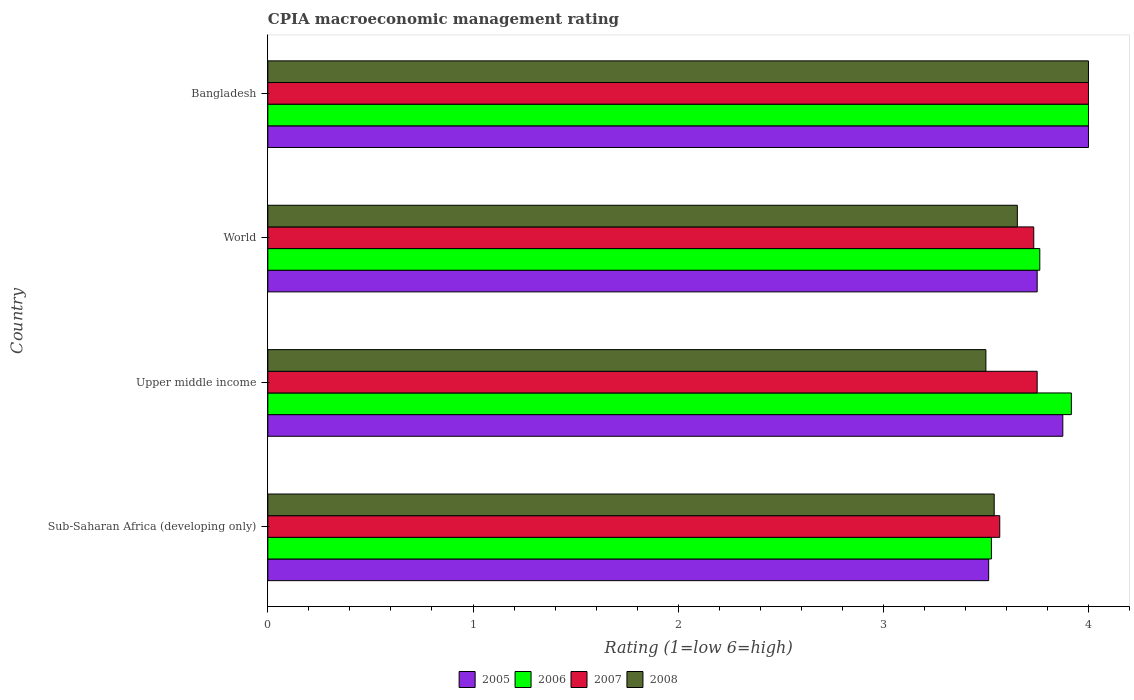Are the number of bars per tick equal to the number of legend labels?
Give a very brief answer. Yes. How many bars are there on the 4th tick from the top?
Give a very brief answer. 4. How many bars are there on the 2nd tick from the bottom?
Your answer should be very brief. 4. What is the label of the 4th group of bars from the top?
Provide a short and direct response. Sub-Saharan Africa (developing only). In how many cases, is the number of bars for a given country not equal to the number of legend labels?
Keep it short and to the point. 0. What is the CPIA rating in 2008 in Bangladesh?
Give a very brief answer. 4. Across all countries, what is the minimum CPIA rating in 2007?
Ensure brevity in your answer.  3.57. In which country was the CPIA rating in 2007 minimum?
Your answer should be compact. Sub-Saharan Africa (developing only). What is the total CPIA rating in 2008 in the graph?
Your answer should be very brief. 14.69. What is the difference between the CPIA rating in 2007 in Bangladesh and the CPIA rating in 2008 in Upper middle income?
Offer a terse response. 0.5. What is the average CPIA rating in 2007 per country?
Provide a short and direct response. 3.76. What is the difference between the CPIA rating in 2005 and CPIA rating in 2008 in Bangladesh?
Offer a very short reply. 0. In how many countries, is the CPIA rating in 2007 greater than 3 ?
Provide a short and direct response. 4. What is the ratio of the CPIA rating in 2008 in Sub-Saharan Africa (developing only) to that in Upper middle income?
Make the answer very short. 1.01. Is the CPIA rating in 2008 in Bangladesh less than that in World?
Offer a terse response. No. What is the difference between the highest and the second highest CPIA rating in 2007?
Ensure brevity in your answer.  0.25. What is the difference between the highest and the lowest CPIA rating in 2007?
Make the answer very short. 0.43. In how many countries, is the CPIA rating in 2005 greater than the average CPIA rating in 2005 taken over all countries?
Offer a terse response. 2. Is the sum of the CPIA rating in 2008 in Bangladesh and Upper middle income greater than the maximum CPIA rating in 2005 across all countries?
Your response must be concise. Yes. What does the 1st bar from the top in Upper middle income represents?
Your answer should be very brief. 2008. What does the 1st bar from the bottom in World represents?
Offer a terse response. 2005. Are all the bars in the graph horizontal?
Provide a short and direct response. Yes. How many countries are there in the graph?
Your answer should be very brief. 4. Does the graph contain any zero values?
Provide a succinct answer. No. How are the legend labels stacked?
Your answer should be compact. Horizontal. What is the title of the graph?
Your answer should be very brief. CPIA macroeconomic management rating. Does "1969" appear as one of the legend labels in the graph?
Offer a terse response. No. What is the label or title of the X-axis?
Make the answer very short. Rating (1=low 6=high). What is the label or title of the Y-axis?
Ensure brevity in your answer.  Country. What is the Rating (1=low 6=high) of 2005 in Sub-Saharan Africa (developing only)?
Your response must be concise. 3.51. What is the Rating (1=low 6=high) of 2006 in Sub-Saharan Africa (developing only)?
Provide a succinct answer. 3.53. What is the Rating (1=low 6=high) in 2007 in Sub-Saharan Africa (developing only)?
Keep it short and to the point. 3.57. What is the Rating (1=low 6=high) in 2008 in Sub-Saharan Africa (developing only)?
Your response must be concise. 3.54. What is the Rating (1=low 6=high) of 2005 in Upper middle income?
Give a very brief answer. 3.88. What is the Rating (1=low 6=high) of 2006 in Upper middle income?
Provide a succinct answer. 3.92. What is the Rating (1=low 6=high) in 2007 in Upper middle income?
Ensure brevity in your answer.  3.75. What is the Rating (1=low 6=high) of 2008 in Upper middle income?
Your response must be concise. 3.5. What is the Rating (1=low 6=high) of 2005 in World?
Give a very brief answer. 3.75. What is the Rating (1=low 6=high) in 2006 in World?
Provide a succinct answer. 3.76. What is the Rating (1=low 6=high) of 2007 in World?
Offer a terse response. 3.73. What is the Rating (1=low 6=high) of 2008 in World?
Your answer should be very brief. 3.65. What is the Rating (1=low 6=high) of 2006 in Bangladesh?
Offer a terse response. 4. What is the Rating (1=low 6=high) of 2007 in Bangladesh?
Your answer should be very brief. 4. Across all countries, what is the maximum Rating (1=low 6=high) of 2006?
Your answer should be compact. 4. Across all countries, what is the maximum Rating (1=low 6=high) in 2007?
Offer a very short reply. 4. Across all countries, what is the minimum Rating (1=low 6=high) in 2005?
Ensure brevity in your answer.  3.51. Across all countries, what is the minimum Rating (1=low 6=high) of 2006?
Provide a succinct answer. 3.53. Across all countries, what is the minimum Rating (1=low 6=high) of 2007?
Offer a terse response. 3.57. Across all countries, what is the minimum Rating (1=low 6=high) in 2008?
Offer a terse response. 3.5. What is the total Rating (1=low 6=high) of 2005 in the graph?
Ensure brevity in your answer.  15.14. What is the total Rating (1=low 6=high) in 2006 in the graph?
Provide a succinct answer. 15.21. What is the total Rating (1=low 6=high) in 2007 in the graph?
Keep it short and to the point. 15.05. What is the total Rating (1=low 6=high) of 2008 in the graph?
Provide a short and direct response. 14.69. What is the difference between the Rating (1=low 6=high) in 2005 in Sub-Saharan Africa (developing only) and that in Upper middle income?
Your answer should be compact. -0.36. What is the difference between the Rating (1=low 6=high) in 2006 in Sub-Saharan Africa (developing only) and that in Upper middle income?
Give a very brief answer. -0.39. What is the difference between the Rating (1=low 6=high) in 2007 in Sub-Saharan Africa (developing only) and that in Upper middle income?
Keep it short and to the point. -0.18. What is the difference between the Rating (1=low 6=high) in 2008 in Sub-Saharan Africa (developing only) and that in Upper middle income?
Offer a terse response. 0.04. What is the difference between the Rating (1=low 6=high) of 2005 in Sub-Saharan Africa (developing only) and that in World?
Ensure brevity in your answer.  -0.24. What is the difference between the Rating (1=low 6=high) in 2006 in Sub-Saharan Africa (developing only) and that in World?
Your answer should be very brief. -0.24. What is the difference between the Rating (1=low 6=high) of 2007 in Sub-Saharan Africa (developing only) and that in World?
Your answer should be very brief. -0.17. What is the difference between the Rating (1=low 6=high) of 2008 in Sub-Saharan Africa (developing only) and that in World?
Give a very brief answer. -0.11. What is the difference between the Rating (1=low 6=high) of 2005 in Sub-Saharan Africa (developing only) and that in Bangladesh?
Offer a terse response. -0.49. What is the difference between the Rating (1=low 6=high) in 2006 in Sub-Saharan Africa (developing only) and that in Bangladesh?
Make the answer very short. -0.47. What is the difference between the Rating (1=low 6=high) in 2007 in Sub-Saharan Africa (developing only) and that in Bangladesh?
Your answer should be very brief. -0.43. What is the difference between the Rating (1=low 6=high) in 2008 in Sub-Saharan Africa (developing only) and that in Bangladesh?
Provide a succinct answer. -0.46. What is the difference between the Rating (1=low 6=high) of 2005 in Upper middle income and that in World?
Your answer should be very brief. 0.12. What is the difference between the Rating (1=low 6=high) of 2006 in Upper middle income and that in World?
Offer a very short reply. 0.15. What is the difference between the Rating (1=low 6=high) of 2007 in Upper middle income and that in World?
Provide a succinct answer. 0.02. What is the difference between the Rating (1=low 6=high) of 2008 in Upper middle income and that in World?
Offer a terse response. -0.15. What is the difference between the Rating (1=low 6=high) of 2005 in Upper middle income and that in Bangladesh?
Your answer should be very brief. -0.12. What is the difference between the Rating (1=low 6=high) in 2006 in Upper middle income and that in Bangladesh?
Give a very brief answer. -0.08. What is the difference between the Rating (1=low 6=high) of 2006 in World and that in Bangladesh?
Your answer should be compact. -0.24. What is the difference between the Rating (1=low 6=high) in 2007 in World and that in Bangladesh?
Give a very brief answer. -0.27. What is the difference between the Rating (1=low 6=high) in 2008 in World and that in Bangladesh?
Your response must be concise. -0.35. What is the difference between the Rating (1=low 6=high) of 2005 in Sub-Saharan Africa (developing only) and the Rating (1=low 6=high) of 2006 in Upper middle income?
Make the answer very short. -0.4. What is the difference between the Rating (1=low 6=high) in 2005 in Sub-Saharan Africa (developing only) and the Rating (1=low 6=high) in 2007 in Upper middle income?
Your answer should be very brief. -0.24. What is the difference between the Rating (1=low 6=high) of 2005 in Sub-Saharan Africa (developing only) and the Rating (1=low 6=high) of 2008 in Upper middle income?
Ensure brevity in your answer.  0.01. What is the difference between the Rating (1=low 6=high) of 2006 in Sub-Saharan Africa (developing only) and the Rating (1=low 6=high) of 2007 in Upper middle income?
Make the answer very short. -0.22. What is the difference between the Rating (1=low 6=high) in 2006 in Sub-Saharan Africa (developing only) and the Rating (1=low 6=high) in 2008 in Upper middle income?
Your response must be concise. 0.03. What is the difference between the Rating (1=low 6=high) in 2007 in Sub-Saharan Africa (developing only) and the Rating (1=low 6=high) in 2008 in Upper middle income?
Offer a terse response. 0.07. What is the difference between the Rating (1=low 6=high) in 2005 in Sub-Saharan Africa (developing only) and the Rating (1=low 6=high) in 2006 in World?
Your response must be concise. -0.25. What is the difference between the Rating (1=low 6=high) of 2005 in Sub-Saharan Africa (developing only) and the Rating (1=low 6=high) of 2007 in World?
Your answer should be very brief. -0.22. What is the difference between the Rating (1=low 6=high) in 2005 in Sub-Saharan Africa (developing only) and the Rating (1=low 6=high) in 2008 in World?
Keep it short and to the point. -0.14. What is the difference between the Rating (1=low 6=high) in 2006 in Sub-Saharan Africa (developing only) and the Rating (1=low 6=high) in 2007 in World?
Your response must be concise. -0.21. What is the difference between the Rating (1=low 6=high) in 2006 in Sub-Saharan Africa (developing only) and the Rating (1=low 6=high) in 2008 in World?
Make the answer very short. -0.13. What is the difference between the Rating (1=low 6=high) in 2007 in Sub-Saharan Africa (developing only) and the Rating (1=low 6=high) in 2008 in World?
Your answer should be compact. -0.09. What is the difference between the Rating (1=low 6=high) in 2005 in Sub-Saharan Africa (developing only) and the Rating (1=low 6=high) in 2006 in Bangladesh?
Offer a very short reply. -0.49. What is the difference between the Rating (1=low 6=high) in 2005 in Sub-Saharan Africa (developing only) and the Rating (1=low 6=high) in 2007 in Bangladesh?
Give a very brief answer. -0.49. What is the difference between the Rating (1=low 6=high) of 2005 in Sub-Saharan Africa (developing only) and the Rating (1=low 6=high) of 2008 in Bangladesh?
Offer a terse response. -0.49. What is the difference between the Rating (1=low 6=high) of 2006 in Sub-Saharan Africa (developing only) and the Rating (1=low 6=high) of 2007 in Bangladesh?
Offer a terse response. -0.47. What is the difference between the Rating (1=low 6=high) in 2006 in Sub-Saharan Africa (developing only) and the Rating (1=low 6=high) in 2008 in Bangladesh?
Your answer should be very brief. -0.47. What is the difference between the Rating (1=low 6=high) of 2007 in Sub-Saharan Africa (developing only) and the Rating (1=low 6=high) of 2008 in Bangladesh?
Offer a very short reply. -0.43. What is the difference between the Rating (1=low 6=high) in 2005 in Upper middle income and the Rating (1=low 6=high) in 2006 in World?
Keep it short and to the point. 0.11. What is the difference between the Rating (1=low 6=high) of 2005 in Upper middle income and the Rating (1=low 6=high) of 2007 in World?
Ensure brevity in your answer.  0.14. What is the difference between the Rating (1=low 6=high) in 2005 in Upper middle income and the Rating (1=low 6=high) in 2008 in World?
Provide a succinct answer. 0.22. What is the difference between the Rating (1=low 6=high) in 2006 in Upper middle income and the Rating (1=low 6=high) in 2007 in World?
Keep it short and to the point. 0.18. What is the difference between the Rating (1=low 6=high) of 2006 in Upper middle income and the Rating (1=low 6=high) of 2008 in World?
Offer a very short reply. 0.26. What is the difference between the Rating (1=low 6=high) in 2007 in Upper middle income and the Rating (1=low 6=high) in 2008 in World?
Provide a short and direct response. 0.1. What is the difference between the Rating (1=low 6=high) of 2005 in Upper middle income and the Rating (1=low 6=high) of 2006 in Bangladesh?
Your answer should be very brief. -0.12. What is the difference between the Rating (1=low 6=high) in 2005 in Upper middle income and the Rating (1=low 6=high) in 2007 in Bangladesh?
Make the answer very short. -0.12. What is the difference between the Rating (1=low 6=high) of 2005 in Upper middle income and the Rating (1=low 6=high) of 2008 in Bangladesh?
Your answer should be very brief. -0.12. What is the difference between the Rating (1=low 6=high) in 2006 in Upper middle income and the Rating (1=low 6=high) in 2007 in Bangladesh?
Keep it short and to the point. -0.08. What is the difference between the Rating (1=low 6=high) of 2006 in Upper middle income and the Rating (1=low 6=high) of 2008 in Bangladesh?
Provide a succinct answer. -0.08. What is the difference between the Rating (1=low 6=high) in 2007 in Upper middle income and the Rating (1=low 6=high) in 2008 in Bangladesh?
Provide a succinct answer. -0.25. What is the difference between the Rating (1=low 6=high) in 2006 in World and the Rating (1=low 6=high) in 2007 in Bangladesh?
Give a very brief answer. -0.24. What is the difference between the Rating (1=low 6=high) of 2006 in World and the Rating (1=low 6=high) of 2008 in Bangladesh?
Give a very brief answer. -0.24. What is the difference between the Rating (1=low 6=high) of 2007 in World and the Rating (1=low 6=high) of 2008 in Bangladesh?
Provide a short and direct response. -0.27. What is the average Rating (1=low 6=high) of 2005 per country?
Your answer should be compact. 3.78. What is the average Rating (1=low 6=high) of 2006 per country?
Provide a short and direct response. 3.8. What is the average Rating (1=low 6=high) of 2007 per country?
Make the answer very short. 3.76. What is the average Rating (1=low 6=high) in 2008 per country?
Keep it short and to the point. 3.67. What is the difference between the Rating (1=low 6=high) of 2005 and Rating (1=low 6=high) of 2006 in Sub-Saharan Africa (developing only)?
Give a very brief answer. -0.01. What is the difference between the Rating (1=low 6=high) in 2005 and Rating (1=low 6=high) in 2007 in Sub-Saharan Africa (developing only)?
Offer a very short reply. -0.05. What is the difference between the Rating (1=low 6=high) of 2005 and Rating (1=low 6=high) of 2008 in Sub-Saharan Africa (developing only)?
Your response must be concise. -0.03. What is the difference between the Rating (1=low 6=high) of 2006 and Rating (1=low 6=high) of 2007 in Sub-Saharan Africa (developing only)?
Offer a terse response. -0.04. What is the difference between the Rating (1=low 6=high) in 2006 and Rating (1=low 6=high) in 2008 in Sub-Saharan Africa (developing only)?
Your answer should be compact. -0.01. What is the difference between the Rating (1=low 6=high) of 2007 and Rating (1=low 6=high) of 2008 in Sub-Saharan Africa (developing only)?
Your answer should be very brief. 0.03. What is the difference between the Rating (1=low 6=high) of 2005 and Rating (1=low 6=high) of 2006 in Upper middle income?
Provide a succinct answer. -0.04. What is the difference between the Rating (1=low 6=high) in 2005 and Rating (1=low 6=high) in 2007 in Upper middle income?
Keep it short and to the point. 0.12. What is the difference between the Rating (1=low 6=high) of 2006 and Rating (1=low 6=high) of 2008 in Upper middle income?
Give a very brief answer. 0.42. What is the difference between the Rating (1=low 6=high) in 2005 and Rating (1=low 6=high) in 2006 in World?
Provide a short and direct response. -0.01. What is the difference between the Rating (1=low 6=high) in 2005 and Rating (1=low 6=high) in 2007 in World?
Ensure brevity in your answer.  0.02. What is the difference between the Rating (1=low 6=high) of 2005 and Rating (1=low 6=high) of 2008 in World?
Your answer should be compact. 0.1. What is the difference between the Rating (1=low 6=high) of 2006 and Rating (1=low 6=high) of 2007 in World?
Your answer should be compact. 0.03. What is the difference between the Rating (1=low 6=high) in 2006 and Rating (1=low 6=high) in 2008 in World?
Keep it short and to the point. 0.11. What is the difference between the Rating (1=low 6=high) of 2007 and Rating (1=low 6=high) of 2008 in World?
Offer a terse response. 0.08. What is the difference between the Rating (1=low 6=high) of 2005 and Rating (1=low 6=high) of 2007 in Bangladesh?
Your response must be concise. 0. What is the ratio of the Rating (1=low 6=high) in 2005 in Sub-Saharan Africa (developing only) to that in Upper middle income?
Make the answer very short. 0.91. What is the ratio of the Rating (1=low 6=high) in 2006 in Sub-Saharan Africa (developing only) to that in Upper middle income?
Your answer should be very brief. 0.9. What is the ratio of the Rating (1=low 6=high) of 2007 in Sub-Saharan Africa (developing only) to that in Upper middle income?
Provide a short and direct response. 0.95. What is the ratio of the Rating (1=low 6=high) in 2008 in Sub-Saharan Africa (developing only) to that in Upper middle income?
Keep it short and to the point. 1.01. What is the ratio of the Rating (1=low 6=high) of 2005 in Sub-Saharan Africa (developing only) to that in World?
Offer a terse response. 0.94. What is the ratio of the Rating (1=low 6=high) in 2006 in Sub-Saharan Africa (developing only) to that in World?
Provide a succinct answer. 0.94. What is the ratio of the Rating (1=low 6=high) in 2007 in Sub-Saharan Africa (developing only) to that in World?
Offer a very short reply. 0.96. What is the ratio of the Rating (1=low 6=high) in 2008 in Sub-Saharan Africa (developing only) to that in World?
Offer a very short reply. 0.97. What is the ratio of the Rating (1=low 6=high) in 2005 in Sub-Saharan Africa (developing only) to that in Bangladesh?
Provide a succinct answer. 0.88. What is the ratio of the Rating (1=low 6=high) of 2006 in Sub-Saharan Africa (developing only) to that in Bangladesh?
Your response must be concise. 0.88. What is the ratio of the Rating (1=low 6=high) of 2007 in Sub-Saharan Africa (developing only) to that in Bangladesh?
Make the answer very short. 0.89. What is the ratio of the Rating (1=low 6=high) in 2008 in Sub-Saharan Africa (developing only) to that in Bangladesh?
Keep it short and to the point. 0.89. What is the ratio of the Rating (1=low 6=high) in 2006 in Upper middle income to that in World?
Offer a very short reply. 1.04. What is the ratio of the Rating (1=low 6=high) of 2007 in Upper middle income to that in World?
Ensure brevity in your answer.  1. What is the ratio of the Rating (1=low 6=high) of 2008 in Upper middle income to that in World?
Offer a terse response. 0.96. What is the ratio of the Rating (1=low 6=high) of 2005 in Upper middle income to that in Bangladesh?
Make the answer very short. 0.97. What is the ratio of the Rating (1=low 6=high) of 2006 in Upper middle income to that in Bangladesh?
Provide a short and direct response. 0.98. What is the ratio of the Rating (1=low 6=high) of 2008 in Upper middle income to that in Bangladesh?
Provide a short and direct response. 0.88. What is the ratio of the Rating (1=low 6=high) in 2006 in World to that in Bangladesh?
Give a very brief answer. 0.94. What is the ratio of the Rating (1=low 6=high) in 2008 in World to that in Bangladesh?
Offer a very short reply. 0.91. What is the difference between the highest and the second highest Rating (1=low 6=high) in 2006?
Your answer should be compact. 0.08. What is the difference between the highest and the second highest Rating (1=low 6=high) of 2008?
Keep it short and to the point. 0.35. What is the difference between the highest and the lowest Rating (1=low 6=high) in 2005?
Keep it short and to the point. 0.49. What is the difference between the highest and the lowest Rating (1=low 6=high) in 2006?
Give a very brief answer. 0.47. What is the difference between the highest and the lowest Rating (1=low 6=high) of 2007?
Your response must be concise. 0.43. What is the difference between the highest and the lowest Rating (1=low 6=high) in 2008?
Offer a very short reply. 0.5. 